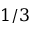Convert formula to latex. <formula><loc_0><loc_0><loc_500><loc_500>1 / 3</formula> 